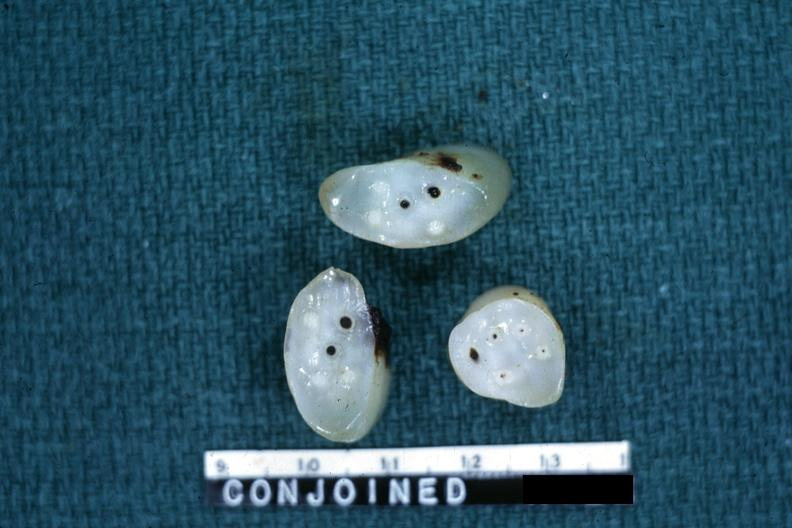s umbilical cord present?
Answer the question using a single word or phrase. Yes 